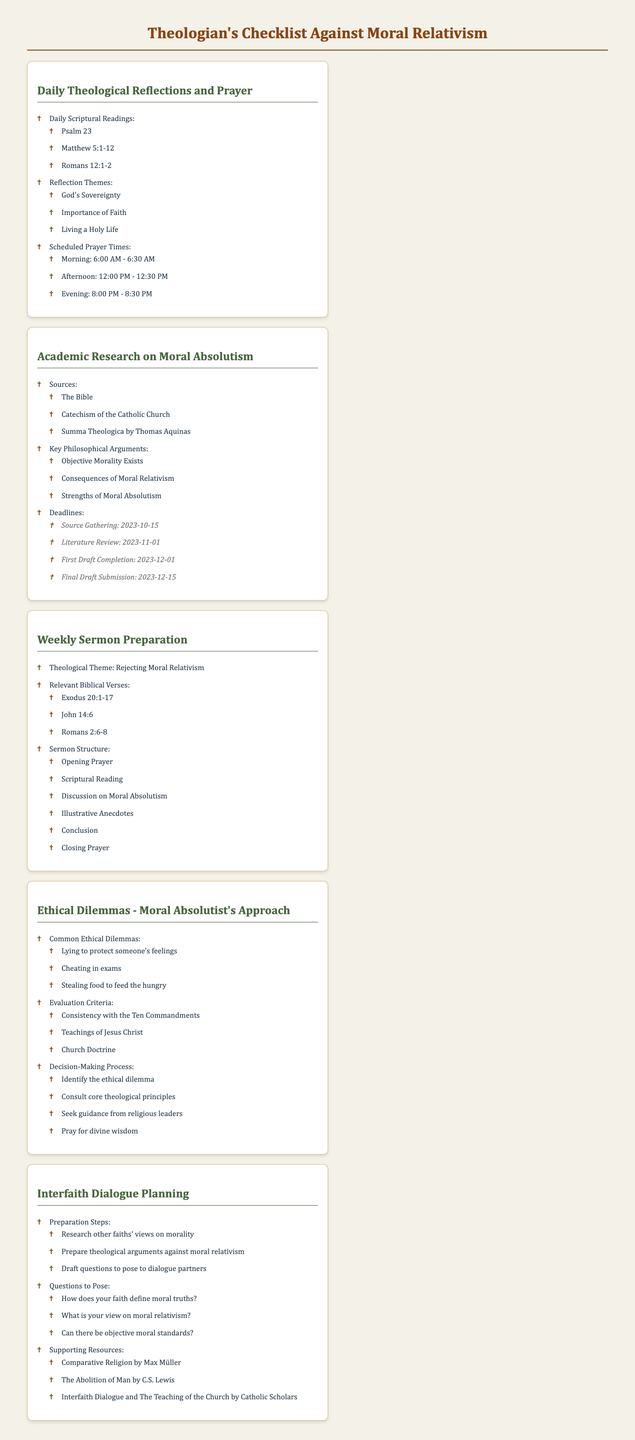What are the daily scriptural readings listed? The question asks for specific items included in the checklist section for daily scriptural readings, which lists Psalm 23, Matthew 5:1-12, and Romans 12:1-2.
Answer: Psalm 23, Matthew 5:1-12, Romans 12:1-2 What is the theological theme for the weekly sermon preparation? This question seeks to identify the main focus of the weekly sermon preparation checklist as outlined in the document.
Answer: Rejecting Moral Relativism When is the deadline for the final draft submission of the academic research? The question pertains to a specific deadline mentioned in the academic research checklist section, identifying when the final draft must be submitted.
Answer: 2023-12-15 What are the common ethical dilemmas listed? This asks for items specifically mentioned in the ethical dilemmas section of the checklist, which includes scenarios for evaluation.
Answer: Lying to protect someone's feelings, Cheating in exams, Stealing food to feed the hungry Which book by Thomas Aquinas is included in the sources for academic research? The inquiry looks for a specific title found in the sources listed within the academic research checklist.
Answer: Summa Theologica What is one of the questions to pose in interfaith dialogue? This question asks for a particular question found in the interfaith dialogue planning checklist that one might ask during discussions with members of different faiths.
Answer: How does your faith define moral truths? 